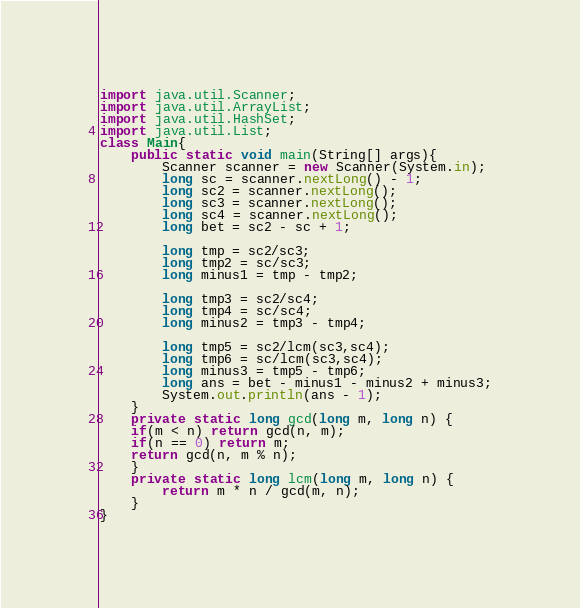Convert code to text. <code><loc_0><loc_0><loc_500><loc_500><_Java_>import java.util.Scanner;
import java.util.ArrayList;
import java.util.HashSet;
import java.util.List;
class Main{
    public static void main(String[] args){
        Scanner scanner = new Scanner(System.in);
        long sc = scanner.nextLong() - 1;
        long sc2 = scanner.nextLong();
        long sc3 = scanner.nextLong();
        long sc4 = scanner.nextLong();
        long bet = sc2 - sc + 1;
        
        long tmp = sc2/sc3;
        long tmp2 = sc/sc3;
        long minus1 = tmp - tmp2;

        long tmp3 = sc2/sc4;
        long tmp4 = sc/sc4;
        long minus2 = tmp3 - tmp4;
        
        long tmp5 = sc2/lcm(sc3,sc4);
        long tmp6 = sc/lcm(sc3,sc4);
        long minus3 = tmp5 - tmp6;
        long ans = bet - minus1 - minus2 + minus3;
        System.out.println(ans - 1);
    }
    private static long gcd(long m, long n) {
    if(m < n) return gcd(n, m);
    if(n == 0) return m;
    return gcd(n, m % n);
    }
    private static long lcm(long m, long n) {
        return m * n / gcd(m, n);
    }
}</code> 